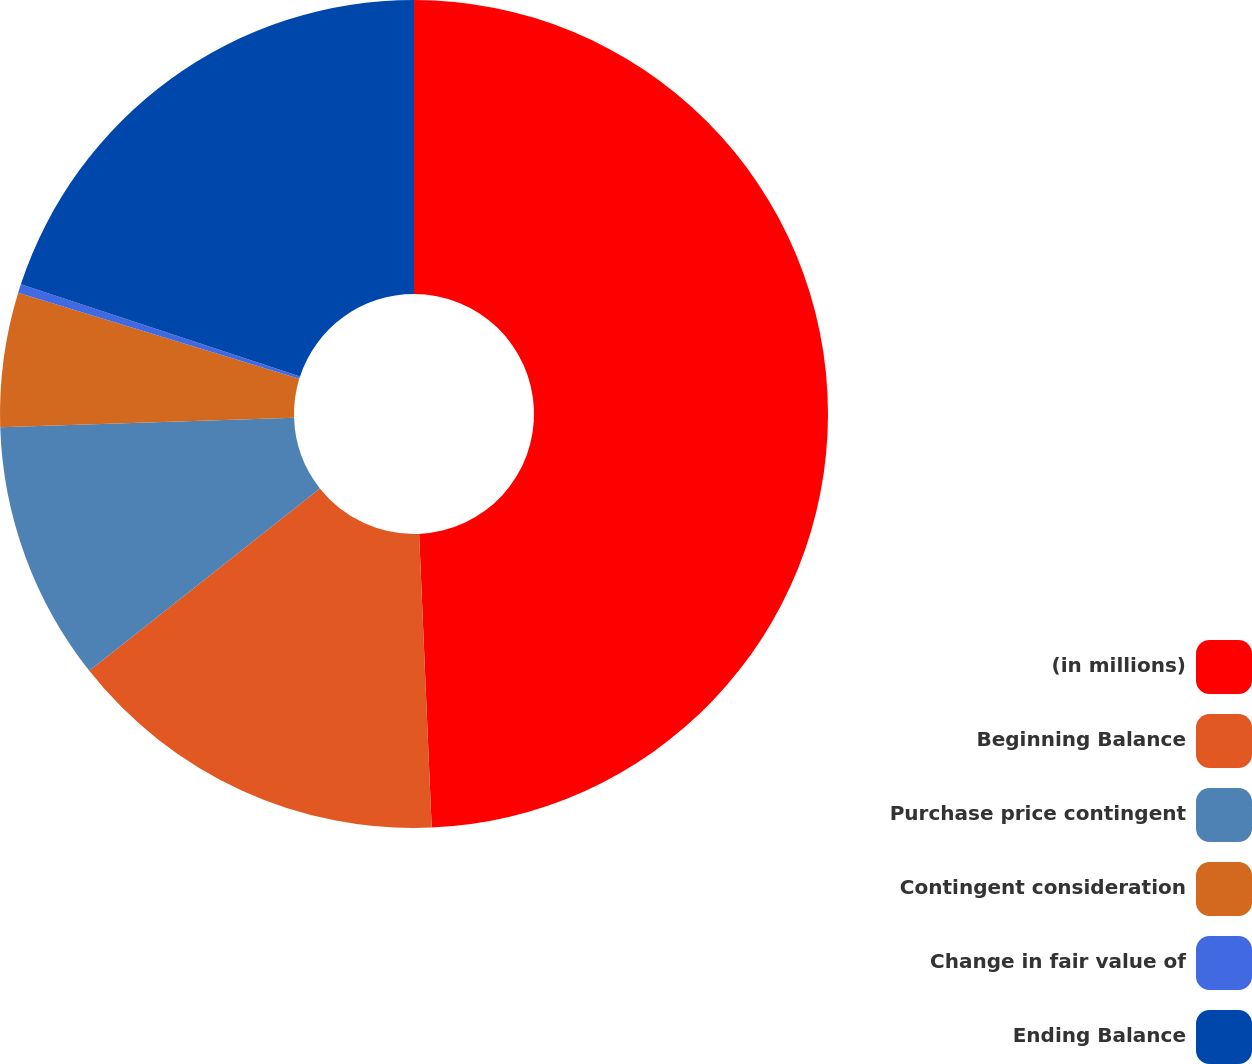Convert chart to OTSL. <chart><loc_0><loc_0><loc_500><loc_500><pie_chart><fcel>(in millions)<fcel>Beginning Balance<fcel>Purchase price contingent<fcel>Contingent consideration<fcel>Change in fair value of<fcel>Ending Balance<nl><fcel>49.32%<fcel>15.03%<fcel>10.14%<fcel>5.24%<fcel>0.34%<fcel>19.93%<nl></chart> 